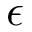Convert formula to latex. <formula><loc_0><loc_0><loc_500><loc_500>\epsilon</formula> 